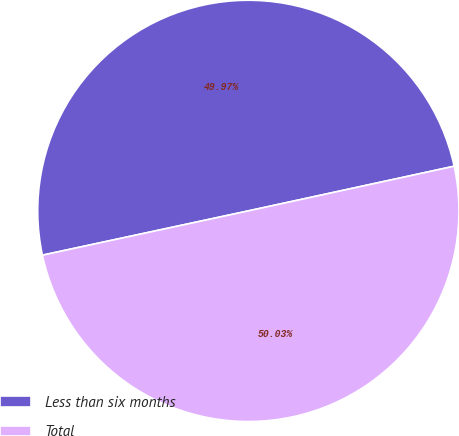<chart> <loc_0><loc_0><loc_500><loc_500><pie_chart><fcel>Less than six months<fcel>Total<nl><fcel>49.97%<fcel>50.03%<nl></chart> 